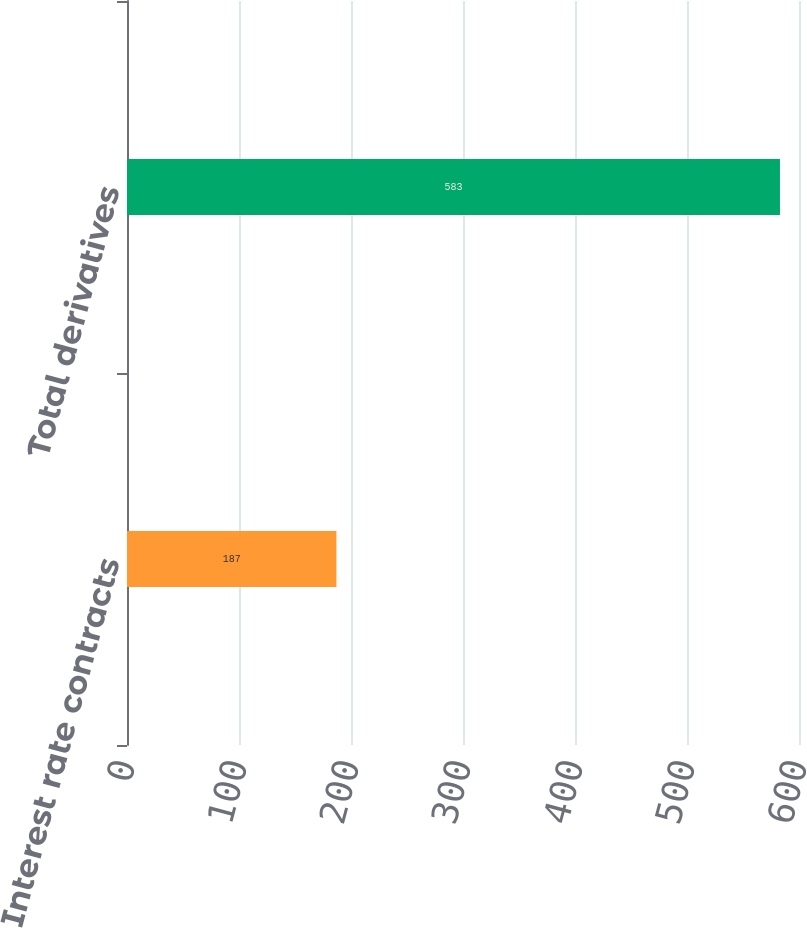Convert chart to OTSL. <chart><loc_0><loc_0><loc_500><loc_500><bar_chart><fcel>Interest rate contracts<fcel>Total derivatives<nl><fcel>187<fcel>583<nl></chart> 